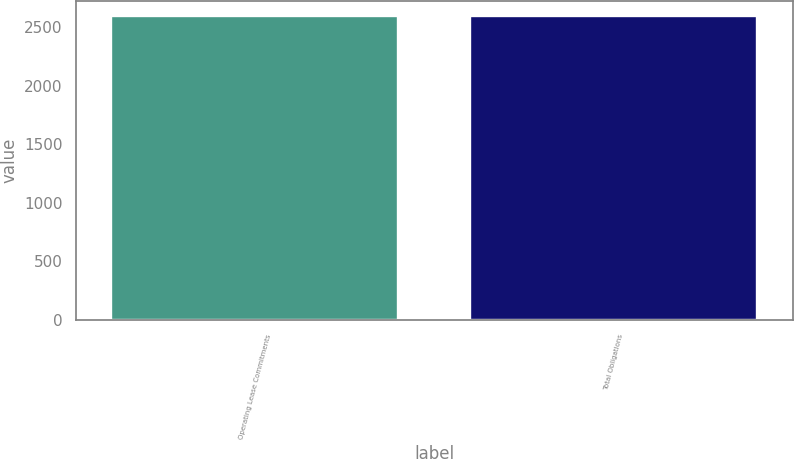<chart> <loc_0><loc_0><loc_500><loc_500><bar_chart><fcel>Operating Lease Commitments<fcel>Total Obligations<nl><fcel>2592<fcel>2592.1<nl></chart> 